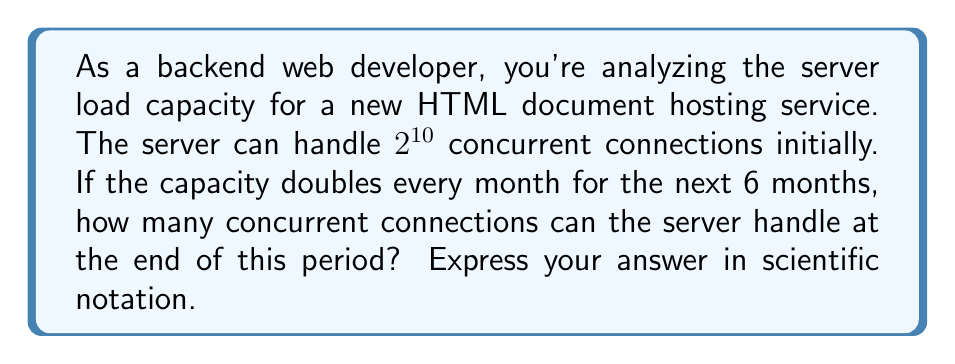Solve this math problem. Let's approach this step-by-step:

1) The initial capacity is $2^{10}$ concurrent connections.

2) The capacity doubles every month for 6 months. This means we need to multiply the initial capacity by 2, six times.

3) Mathematically, this can be expressed as:

   $2^{10} \cdot 2^6 = 2^{10+6} = 2^{16}$

4) Now, let's calculate $2^{16}$:

   $2^{16} = 65,536$

5) To express this in scientific notation, we need to move the decimal point to have a number between 1 and 10, followed by $\times 10^n$:

   $65,536 = 6.5536 \times 10^4$

Thus, after 6 months, the server can handle $6.5536 \times 10^4$ concurrent connections.
Answer: $6.5536 \times 10^4$ concurrent connections 